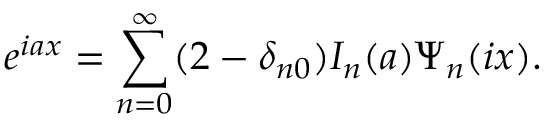<formula> <loc_0><loc_0><loc_500><loc_500>e ^ { i a x } = \sum _ { n = 0 } ^ { \infty } ( 2 - \delta _ { n 0 } ) I _ { n } ( a ) \Psi _ { n } ( i x ) .</formula> 